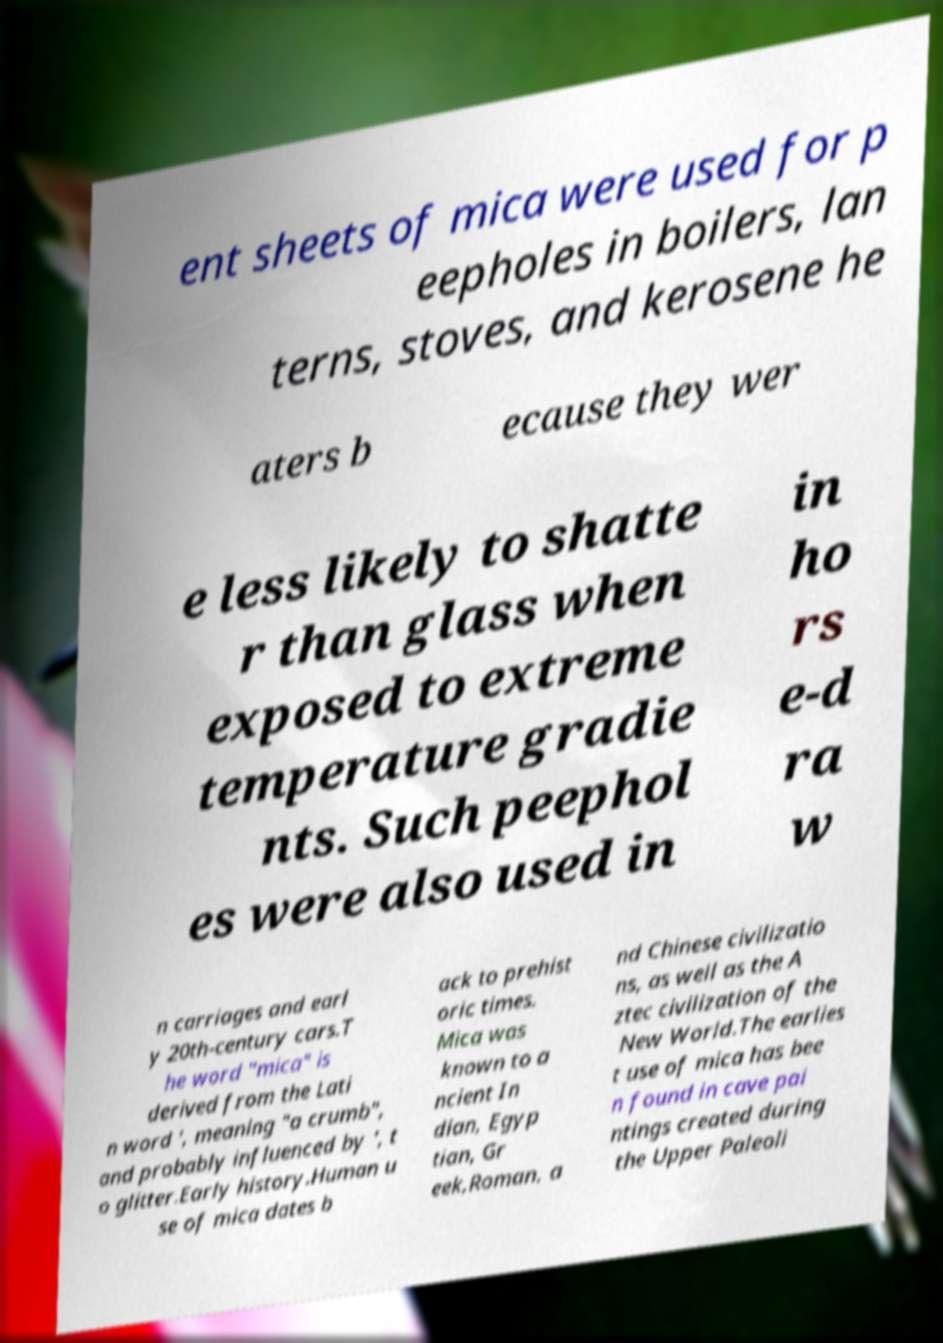There's text embedded in this image that I need extracted. Can you transcribe it verbatim? ent sheets of mica were used for p eepholes in boilers, lan terns, stoves, and kerosene he aters b ecause they wer e less likely to shatte r than glass when exposed to extreme temperature gradie nts. Such peephol es were also used in in ho rs e-d ra w n carriages and earl y 20th-century cars.T he word "mica" is derived from the Lati n word ', meaning "a crumb", and probably influenced by ', t o glitter.Early history.Human u se of mica dates b ack to prehist oric times. Mica was known to a ncient In dian, Egyp tian, Gr eek,Roman, a nd Chinese civilizatio ns, as well as the A ztec civilization of the New World.The earlies t use of mica has bee n found in cave pai ntings created during the Upper Paleoli 